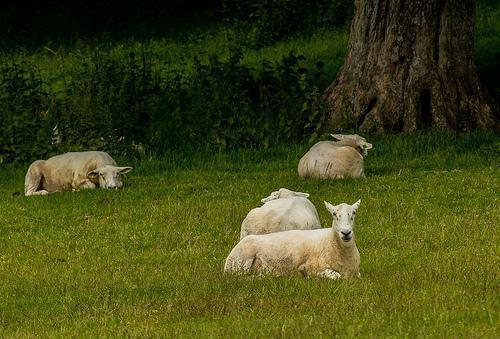How many sheep are there?
Give a very brief answer. 4. How many large trees are there?
Give a very brief answer. 1. 